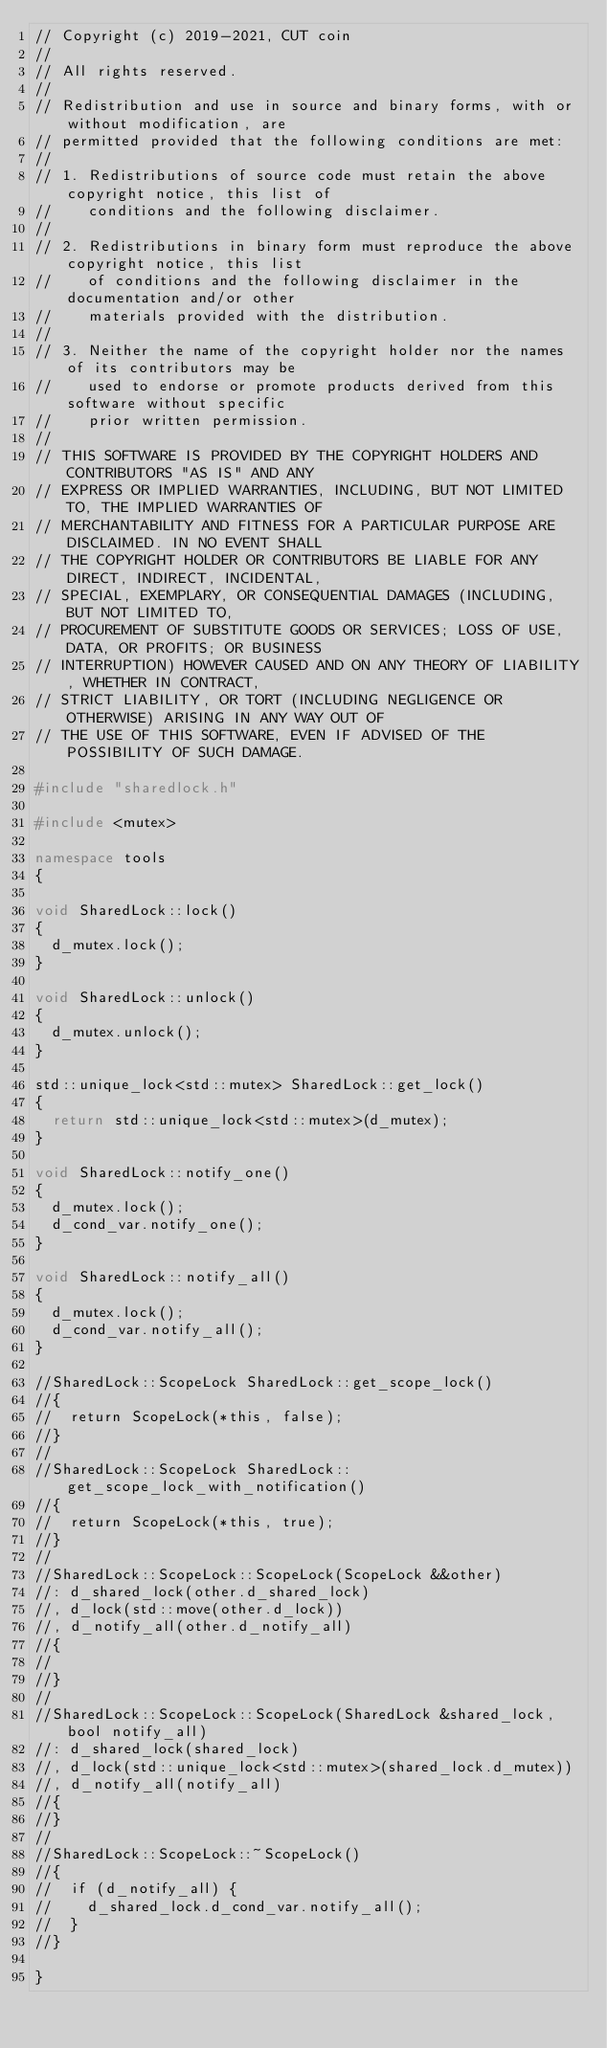<code> <loc_0><loc_0><loc_500><loc_500><_C++_>// Copyright (c) 2019-2021, CUT coin
//
// All rights reserved.
//
// Redistribution and use in source and binary forms, with or without modification, are
// permitted provided that the following conditions are met:
//
// 1. Redistributions of source code must retain the above copyright notice, this list of
//    conditions and the following disclaimer.
//
// 2. Redistributions in binary form must reproduce the above copyright notice, this list
//    of conditions and the following disclaimer in the documentation and/or other
//    materials provided with the distribution.
//
// 3. Neither the name of the copyright holder nor the names of its contributors may be
//    used to endorse or promote products derived from this software without specific
//    prior written permission.
//
// THIS SOFTWARE IS PROVIDED BY THE COPYRIGHT HOLDERS AND CONTRIBUTORS "AS IS" AND ANY
// EXPRESS OR IMPLIED WARRANTIES, INCLUDING, BUT NOT LIMITED TO, THE IMPLIED WARRANTIES OF
// MERCHANTABILITY AND FITNESS FOR A PARTICULAR PURPOSE ARE DISCLAIMED. IN NO EVENT SHALL
// THE COPYRIGHT HOLDER OR CONTRIBUTORS BE LIABLE FOR ANY DIRECT, INDIRECT, INCIDENTAL,
// SPECIAL, EXEMPLARY, OR CONSEQUENTIAL DAMAGES (INCLUDING, BUT NOT LIMITED TO,
// PROCUREMENT OF SUBSTITUTE GOODS OR SERVICES; LOSS OF USE, DATA, OR PROFITS; OR BUSINESS
// INTERRUPTION) HOWEVER CAUSED AND ON ANY THEORY OF LIABILITY, WHETHER IN CONTRACT,
// STRICT LIABILITY, OR TORT (INCLUDING NEGLIGENCE OR OTHERWISE) ARISING IN ANY WAY OUT OF
// THE USE OF THIS SOFTWARE, EVEN IF ADVISED OF THE POSSIBILITY OF SUCH DAMAGE.

#include "sharedlock.h"

#include <mutex>

namespace tools
{

void SharedLock::lock()
{
  d_mutex.lock();
}

void SharedLock::unlock()
{
  d_mutex.unlock();
}

std::unique_lock<std::mutex> SharedLock::get_lock()
{
  return std::unique_lock<std::mutex>(d_mutex);
}

void SharedLock::notify_one()
{
  d_mutex.lock();
  d_cond_var.notify_one();
}

void SharedLock::notify_all()
{
  d_mutex.lock();
  d_cond_var.notify_all();
}

//SharedLock::ScopeLock SharedLock::get_scope_lock()
//{
//  return ScopeLock(*this, false);
//}
//
//SharedLock::ScopeLock SharedLock::get_scope_lock_with_notification()
//{
//  return ScopeLock(*this, true);
//}
//
//SharedLock::ScopeLock::ScopeLock(ScopeLock &&other)
//: d_shared_lock(other.d_shared_lock)
//, d_lock(std::move(other.d_lock))
//, d_notify_all(other.d_notify_all)
//{
//
//}
//
//SharedLock::ScopeLock::ScopeLock(SharedLock &shared_lock, bool notify_all)
//: d_shared_lock(shared_lock)
//, d_lock(std::unique_lock<std::mutex>(shared_lock.d_mutex))
//, d_notify_all(notify_all)
//{
//}
//
//SharedLock::ScopeLock::~ScopeLock()
//{
//  if (d_notify_all) {
//    d_shared_lock.d_cond_var.notify_all();
//  }
//}

}
</code> 